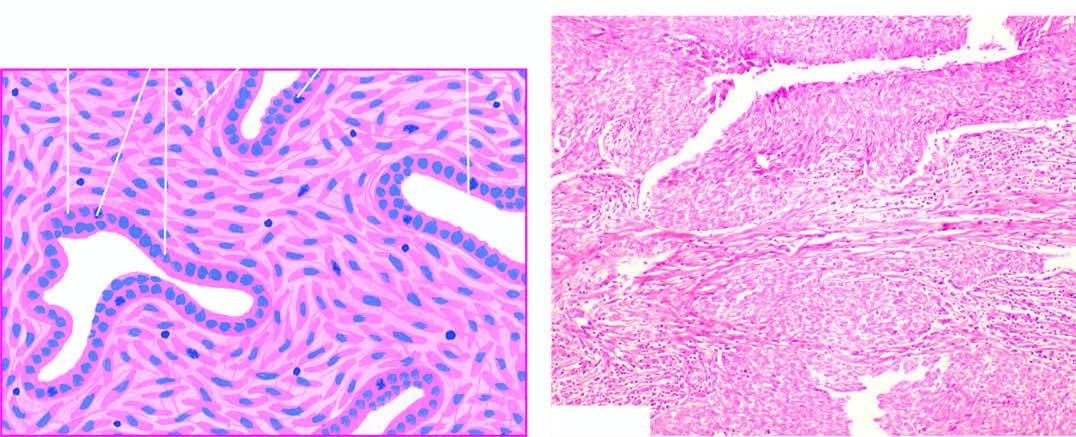did spindle cell areas form fibrosarcoma-like growth pattern?
Answer the question using a single word or phrase. Yes 